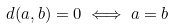Convert formula to latex. <formula><loc_0><loc_0><loc_500><loc_500>d ( a , b ) = 0 \iff a = b</formula> 